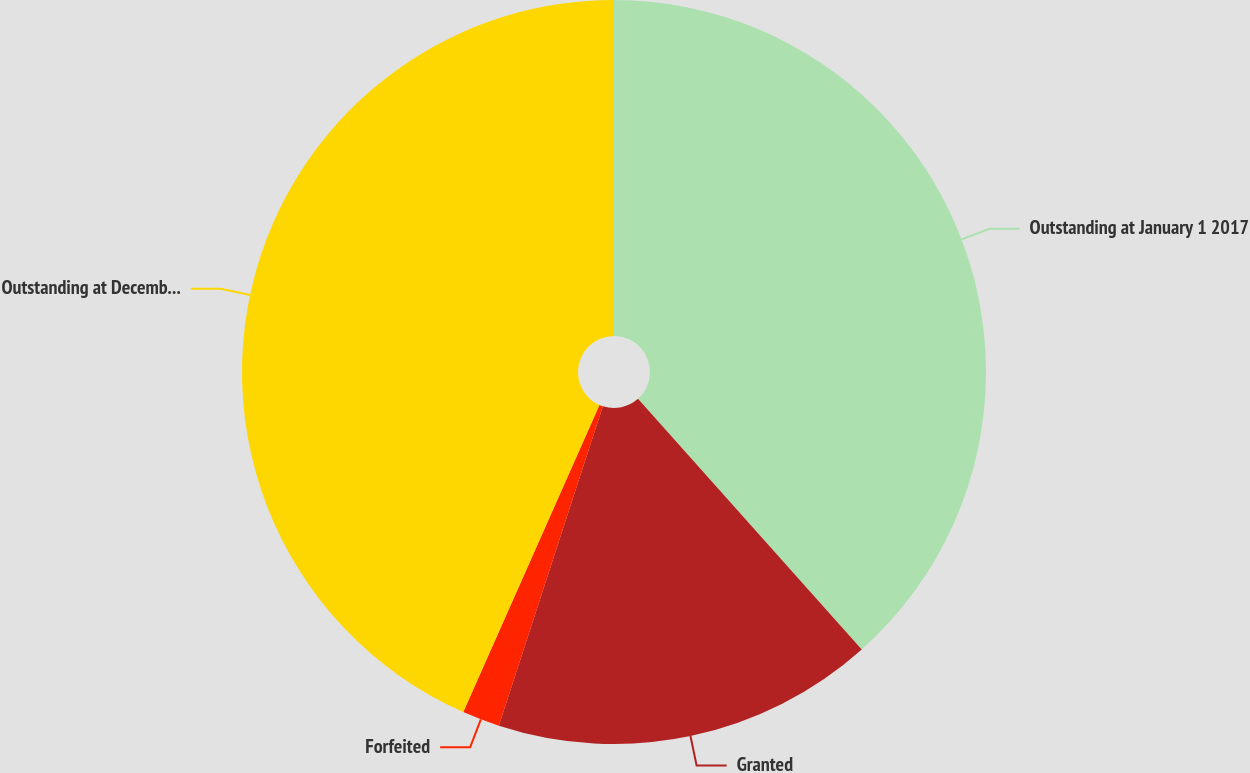Convert chart to OTSL. <chart><loc_0><loc_0><loc_500><loc_500><pie_chart><fcel>Outstanding at January 1 2017<fcel>Granted<fcel>Forfeited<fcel>Outstanding at December 31<nl><fcel>38.4%<fcel>16.61%<fcel>1.63%<fcel>43.36%<nl></chart> 